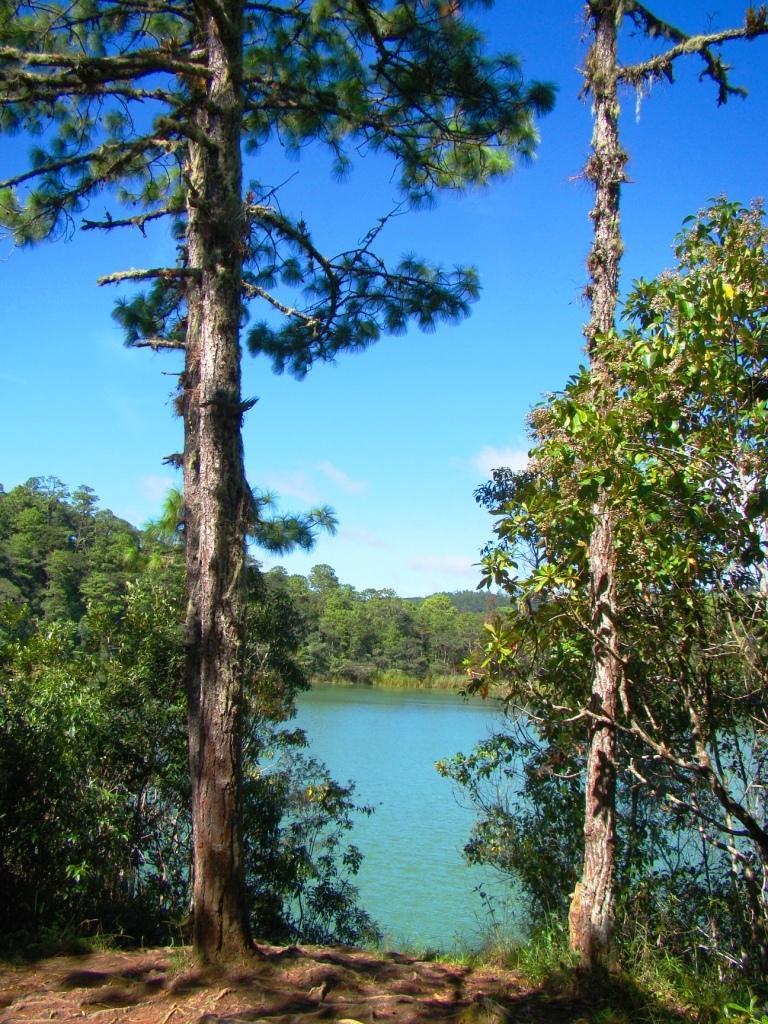Describe this image in one or two sentences. In this image I can see the water and many trees. In the background I can see the clouds and the blue sky. 